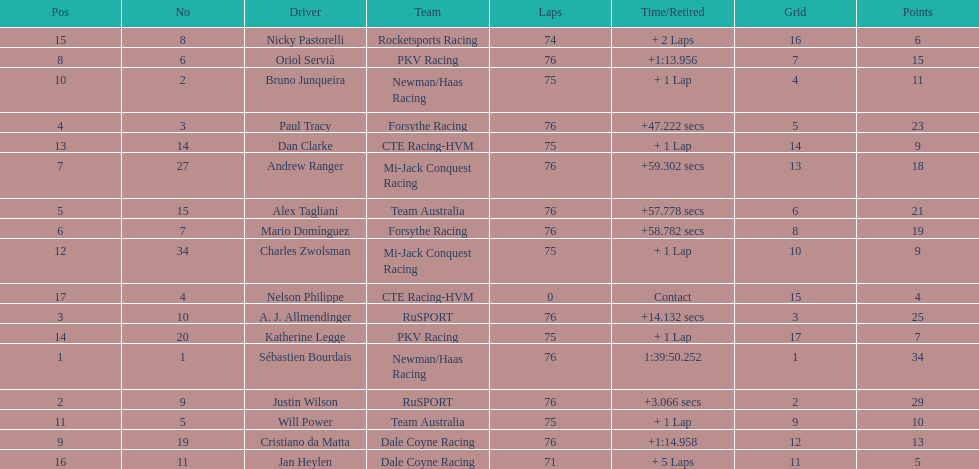Charles zwolsman acquired the same number of points as who? Dan Clarke. Give me the full table as a dictionary. {'header': ['Pos', 'No', 'Driver', 'Team', 'Laps', 'Time/Retired', 'Grid', 'Points'], 'rows': [['15', '8', 'Nicky Pastorelli', 'Rocketsports Racing', '74', '+ 2 Laps', '16', '6'], ['8', '6', 'Oriol Servià', 'PKV Racing', '76', '+1:13.956', '7', '15'], ['10', '2', 'Bruno Junqueira', 'Newman/Haas Racing', '75', '+ 1 Lap', '4', '11'], ['4', '3', 'Paul Tracy', 'Forsythe Racing', '76', '+47.222 secs', '5', '23'], ['13', '14', 'Dan Clarke', 'CTE Racing-HVM', '75', '+ 1 Lap', '14', '9'], ['7', '27', 'Andrew Ranger', 'Mi-Jack Conquest Racing', '76', '+59.302 secs', '13', '18'], ['5', '15', 'Alex Tagliani', 'Team Australia', '76', '+57.778 secs', '6', '21'], ['6', '7', 'Mario Domínguez', 'Forsythe Racing', '76', '+58.782 secs', '8', '19'], ['12', '34', 'Charles Zwolsman', 'Mi-Jack Conquest Racing', '75', '+ 1 Lap', '10', '9'], ['17', '4', 'Nelson Philippe', 'CTE Racing-HVM', '0', 'Contact', '15', '4'], ['3', '10', 'A. J. Allmendinger', 'RuSPORT', '76', '+14.132 secs', '3', '25'], ['14', '20', 'Katherine Legge', 'PKV Racing', '75', '+ 1 Lap', '17', '7'], ['1', '1', 'Sébastien Bourdais', 'Newman/Haas Racing', '76', '1:39:50.252', '1', '34'], ['2', '9', 'Justin Wilson', 'RuSPORT', '76', '+3.066 secs', '2', '29'], ['11', '5', 'Will Power', 'Team Australia', '75', '+ 1 Lap', '9', '10'], ['9', '19', 'Cristiano da Matta', 'Dale Coyne Racing', '76', '+1:14.958', '12', '13'], ['16', '11', 'Jan Heylen', 'Dale Coyne Racing', '71', '+ 5 Laps', '11', '5']]} 